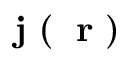Convert formula to latex. <formula><loc_0><loc_0><loc_500><loc_500>j ( r )</formula> 